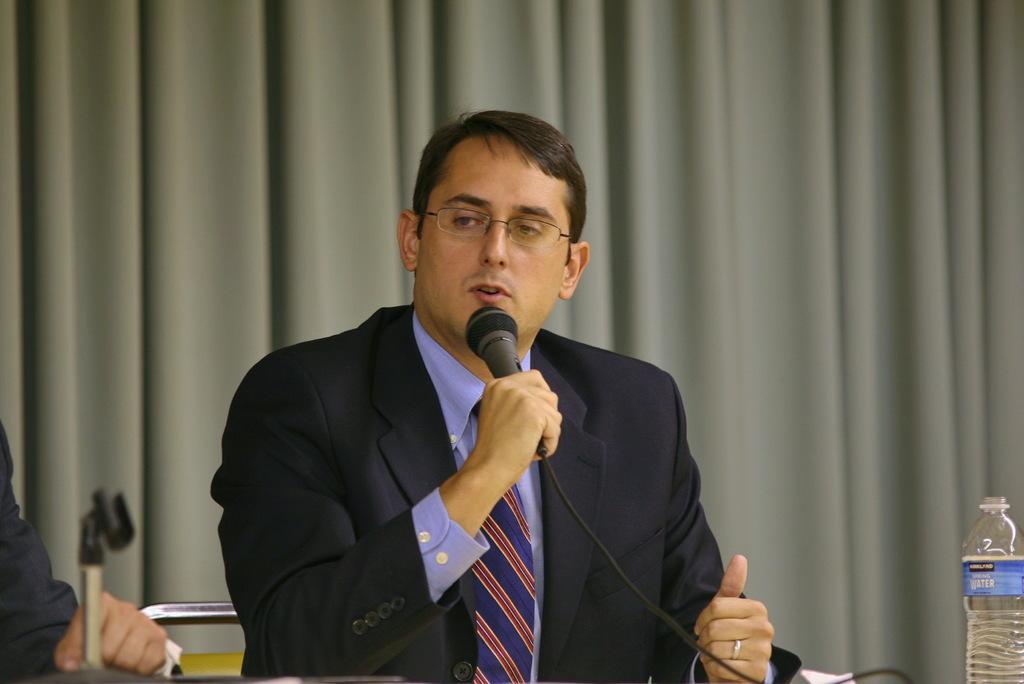Please provide a concise description of this image. A person wearing a coat and a tie is holding a mic wearing specs and talking. On the right corner there is a bottle. On the left corner there is a mic stand. In the background there is a curtain. 